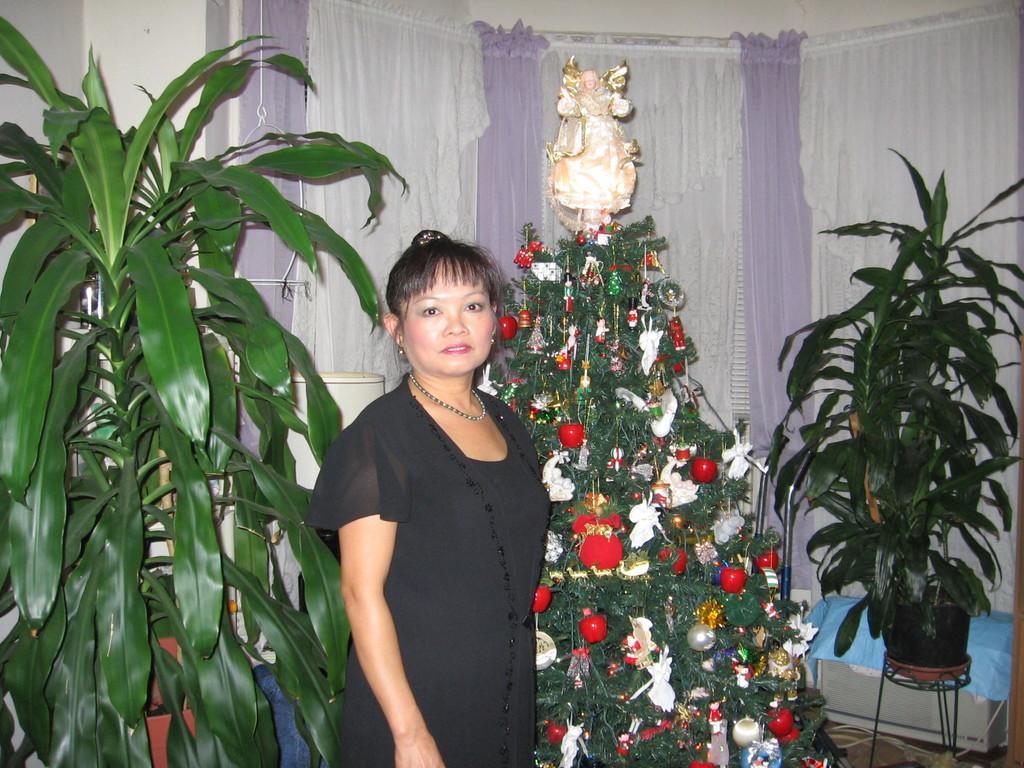Can you describe this image briefly? In this image there is a woman in the middle who is wearing the black dress. In the background there are plants on either side of her. Beside her there is a Christmas tree to which there are decorative items all over the tree. In the background there are curtains. 